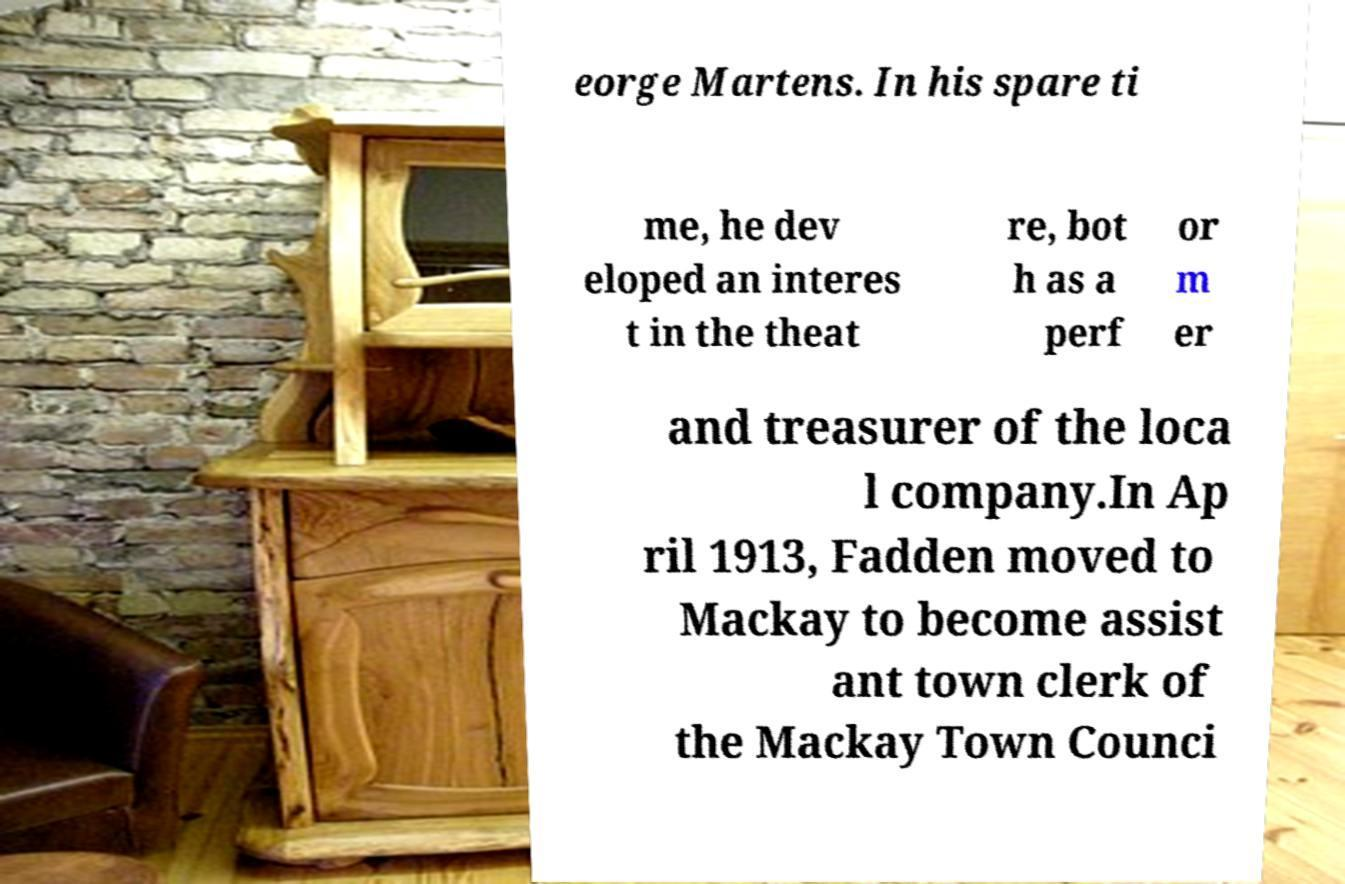For documentation purposes, I need the text within this image transcribed. Could you provide that? eorge Martens. In his spare ti me, he dev eloped an interes t in the theat re, bot h as a perf or m er and treasurer of the loca l company.In Ap ril 1913, Fadden moved to Mackay to become assist ant town clerk of the Mackay Town Counci 